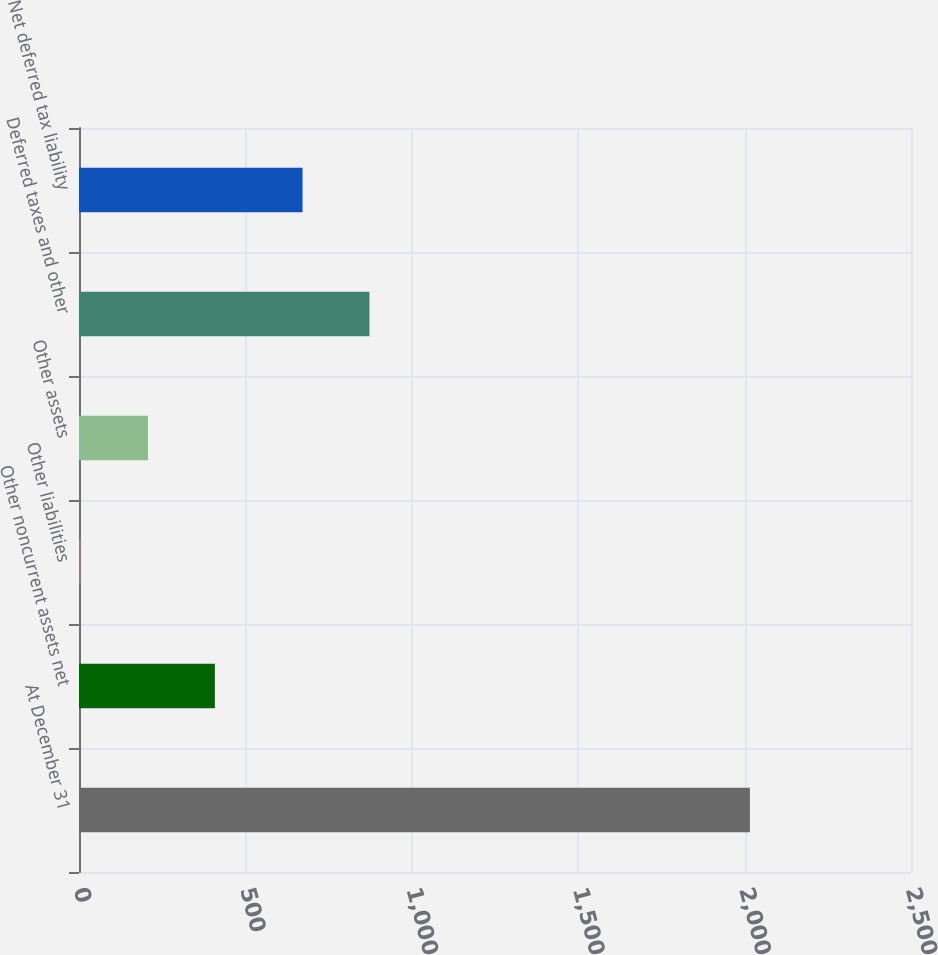<chart> <loc_0><loc_0><loc_500><loc_500><bar_chart><fcel>At December 31<fcel>Other noncurrent assets net<fcel>Other liabilities<fcel>Other assets<fcel>Deferred taxes and other<fcel>Net deferred tax liability<nl><fcel>2016<fcel>408.24<fcel>6.3<fcel>207.27<fcel>872.67<fcel>671.7<nl></chart> 